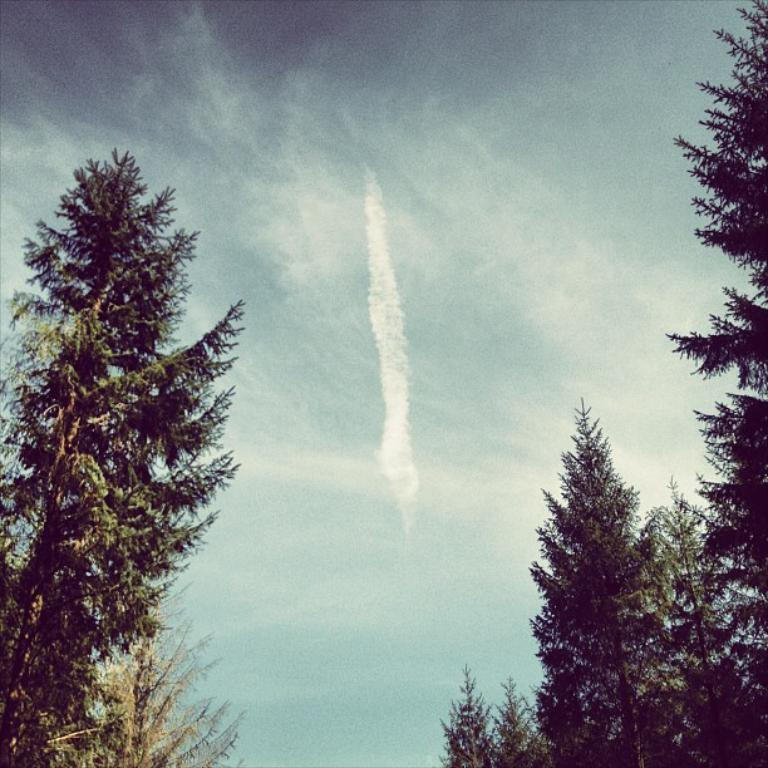What type of vegetation can be seen in the image? There are trees in the image. What is the condition of the sky in the image? The sky is cloudy in the image. What date is marked on the calendar in the image? There is no calendar present in the image. What type of potato can be seen growing near the trees in the image? There are no potatoes visible in the image; only trees are present. 